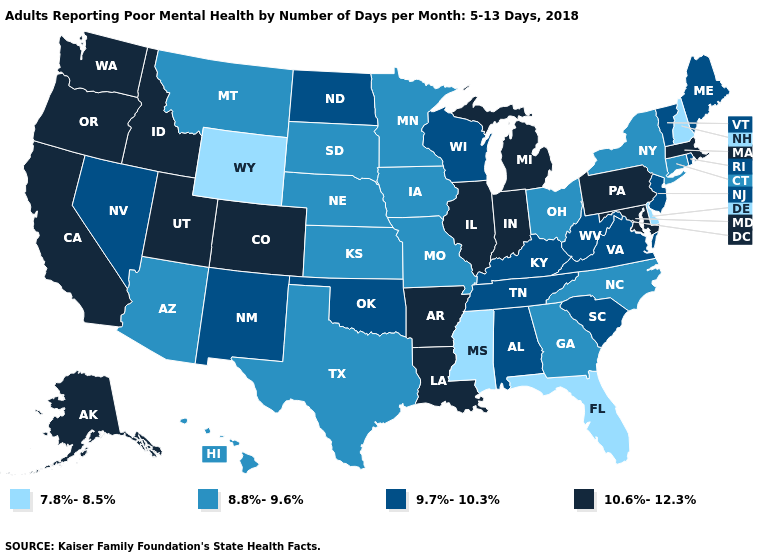Does the map have missing data?
Give a very brief answer. No. Does West Virginia have the lowest value in the USA?
Write a very short answer. No. Does South Dakota have the same value as Oregon?
Give a very brief answer. No. Name the states that have a value in the range 8.8%-9.6%?
Quick response, please. Arizona, Connecticut, Georgia, Hawaii, Iowa, Kansas, Minnesota, Missouri, Montana, Nebraska, New York, North Carolina, Ohio, South Dakota, Texas. Name the states that have a value in the range 9.7%-10.3%?
Short answer required. Alabama, Kentucky, Maine, Nevada, New Jersey, New Mexico, North Dakota, Oklahoma, Rhode Island, South Carolina, Tennessee, Vermont, Virginia, West Virginia, Wisconsin. Does Florida have the lowest value in the USA?
Be succinct. Yes. Name the states that have a value in the range 7.8%-8.5%?
Keep it brief. Delaware, Florida, Mississippi, New Hampshire, Wyoming. Does Indiana have the highest value in the MidWest?
Keep it brief. Yes. How many symbols are there in the legend?
Give a very brief answer. 4. Does Wyoming have the lowest value in the USA?
Concise answer only. Yes. What is the value of North Dakota?
Concise answer only. 9.7%-10.3%. What is the value of Rhode Island?
Short answer required. 9.7%-10.3%. Among the states that border Rhode Island , which have the lowest value?
Short answer required. Connecticut. Does New Jersey have a higher value than Missouri?
Keep it brief. Yes. Among the states that border New Jersey , does Pennsylvania have the highest value?
Concise answer only. Yes. 